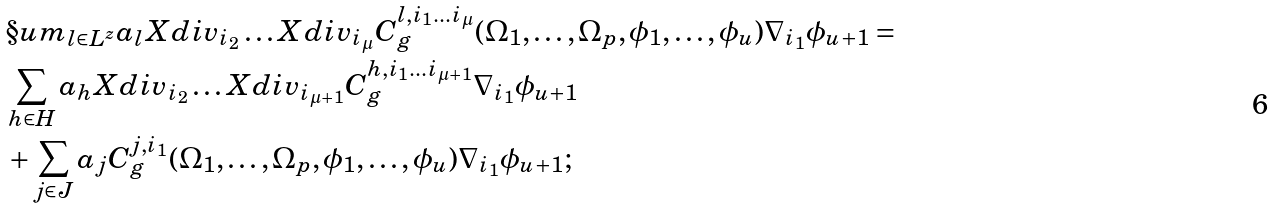Convert formula to latex. <formula><loc_0><loc_0><loc_500><loc_500>& \S u m _ { l \in L ^ { z } } a _ { l } X d i v _ { i _ { 2 } } \dots X d i v _ { i _ { \mu } } C ^ { l , i _ { 1 } \dots i _ { \mu } } _ { g } ( \Omega _ { 1 } , \dots , \Omega _ { p } , \phi _ { 1 } , \dots , \phi _ { u } ) \nabla _ { i _ { 1 } } \phi _ { u + 1 } = \\ & \sum _ { h \in H } a _ { h } X d i v _ { i _ { 2 } } \dots X d i v _ { i _ { \mu + 1 } } C ^ { h , i _ { 1 } \dots i _ { \mu + 1 } } _ { g } \nabla _ { i _ { 1 } } \phi _ { u + 1 } \\ & + \sum _ { j \in J } a _ { j } C ^ { j , i _ { 1 } } _ { g } ( \Omega _ { 1 } , \dots , \Omega _ { p } , \phi _ { 1 } , \dots , \phi _ { u } ) \nabla _ { i _ { 1 } } \phi _ { u + 1 } ;</formula> 